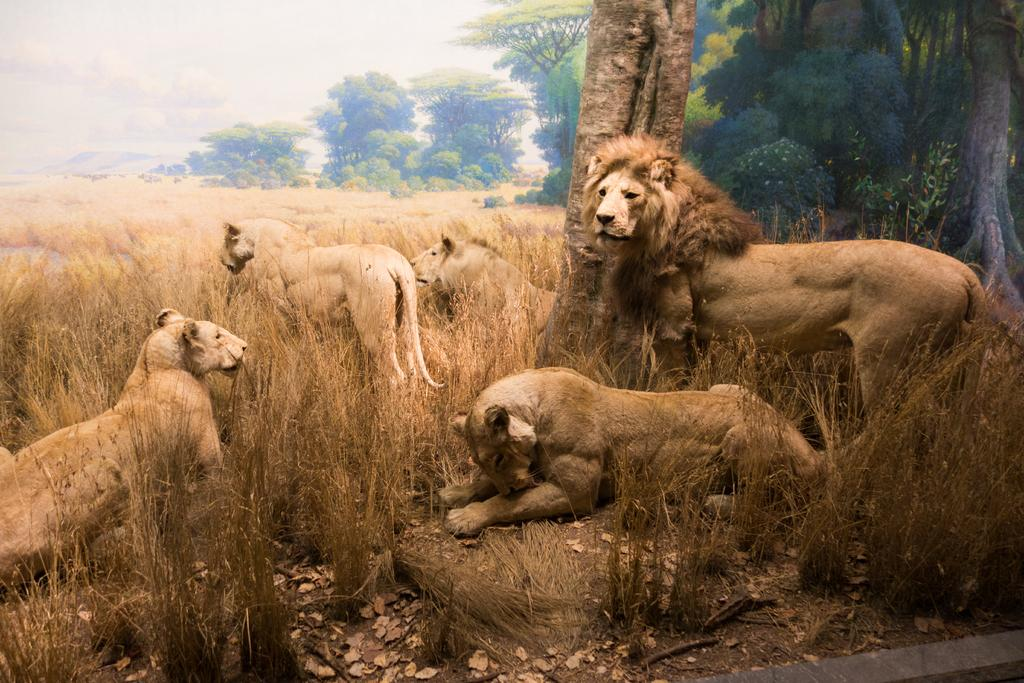What type of animal sculptures are in the image? There are lion sculptures in the image. What type of natural environment is visible in the image? There is grass and trees visible in the image. What is visible in the background of the image? The sky is visible in the image. What type of pencil can be seen in the image? There is no pencil present in the image. Is the image a work of fiction or non-fiction? The image itself is neither fiction nor non-fiction; it is a photograph or illustration. What type of disease can be seen affecting the lion sculptures in the image? There is no disease present in the image; it features lion sculptures and natural elements. 